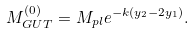Convert formula to latex. <formula><loc_0><loc_0><loc_500><loc_500>M _ { G U T } ^ { ( 0 ) } = M _ { p l } e ^ { - k ( y _ { 2 } - 2 y _ { 1 } ) } . \,</formula> 